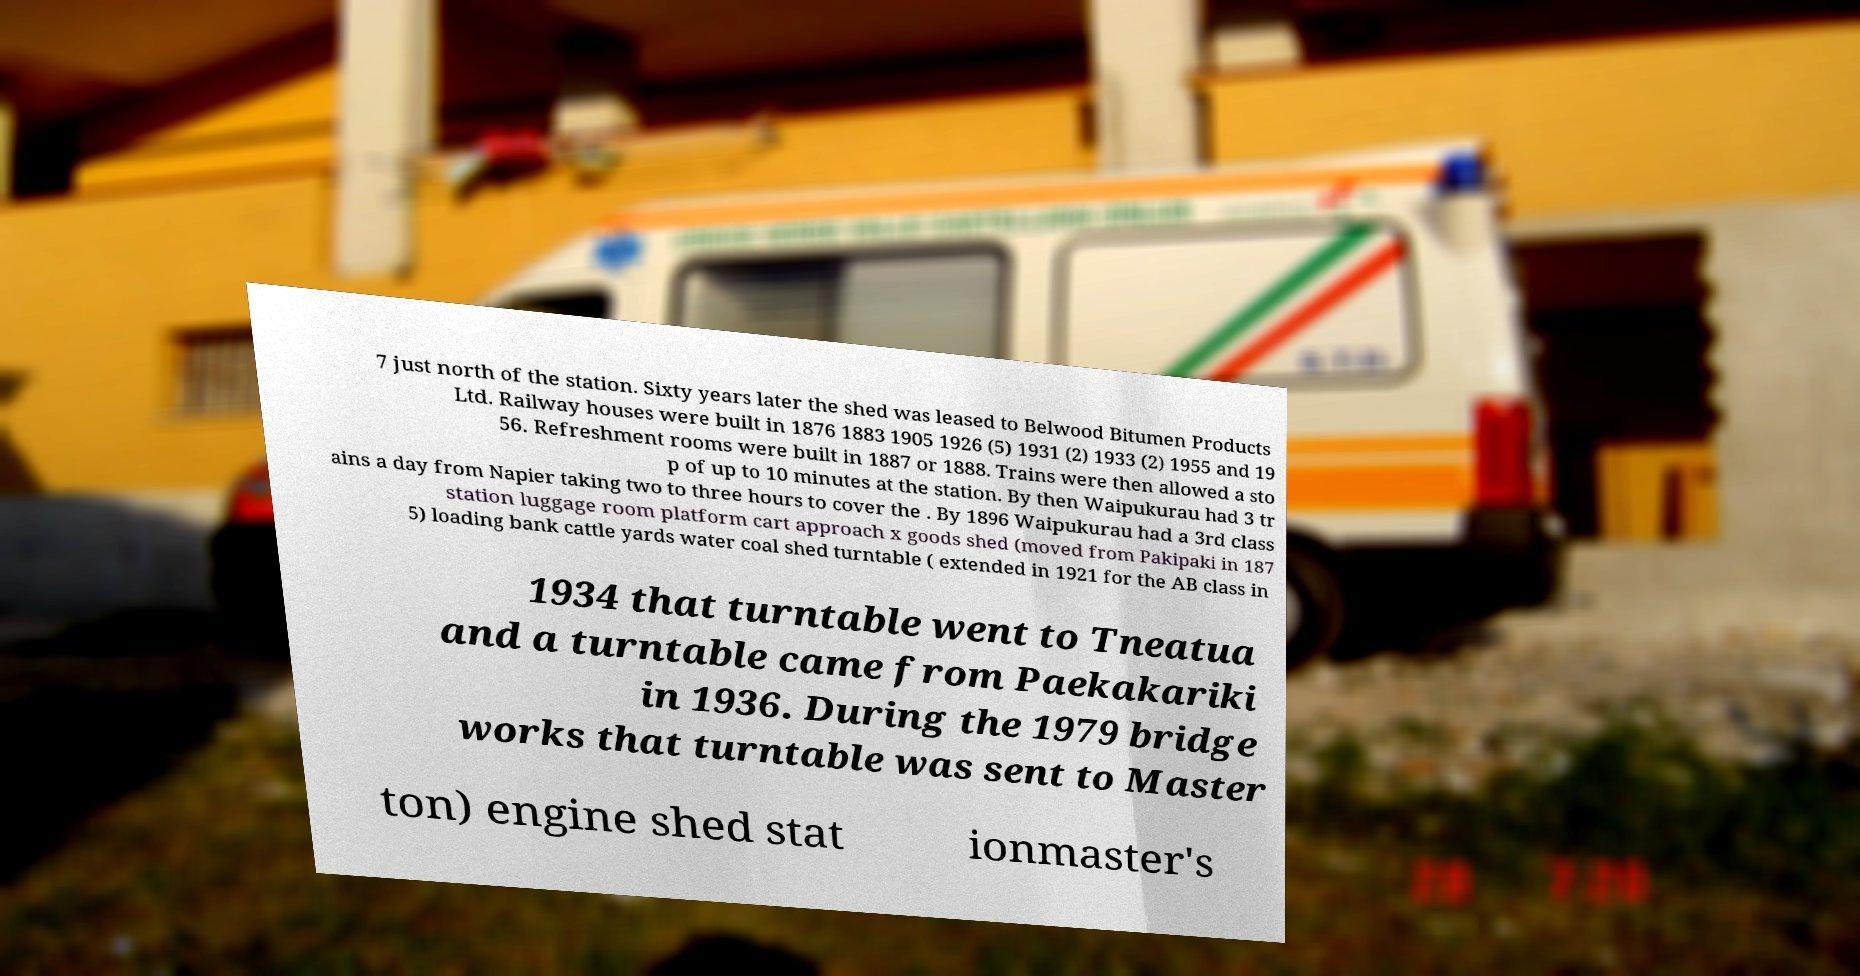Please read and relay the text visible in this image. What does it say? 7 just north of the station. Sixty years later the shed was leased to Belwood Bitumen Products Ltd. Railway houses were built in 1876 1883 1905 1926 (5) 1931 (2) 1933 (2) 1955 and 19 56. Refreshment rooms were built in 1887 or 1888. Trains were then allowed a sto p of up to 10 minutes at the station. By then Waipukurau had 3 tr ains a day from Napier taking two to three hours to cover the . By 1896 Waipukurau had a 3rd class station luggage room platform cart approach x goods shed (moved from Pakipaki in 187 5) loading bank cattle yards water coal shed turntable ( extended in 1921 for the AB class in 1934 that turntable went to Tneatua and a turntable came from Paekakariki in 1936. During the 1979 bridge works that turntable was sent to Master ton) engine shed stat ionmaster's 